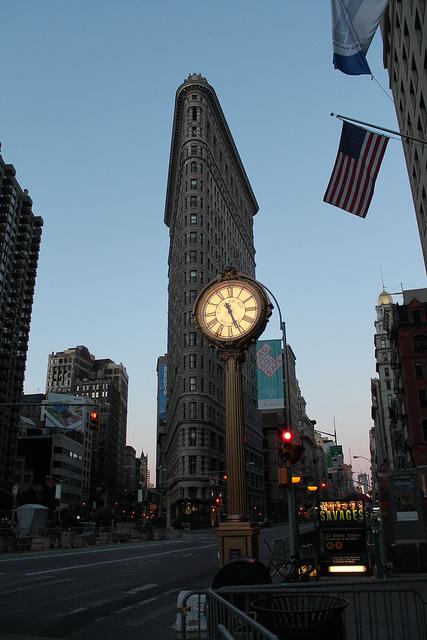Why is the clock lit up?
Be succinct. It's dark. Was the picture taken at night?
Answer briefly. No. What nation's flag is visible?
Write a very short answer. Usa. What time was it when this picture was taken?
Keep it brief. 5:25. What does the bottom sign say?
Short answer required. Savages. What is the time?
Give a very brief answer. 5:26. 